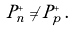<formula> <loc_0><loc_0><loc_500><loc_500>P _ { n } ^ { + } \neq P _ { p } ^ { + } \, .</formula> 